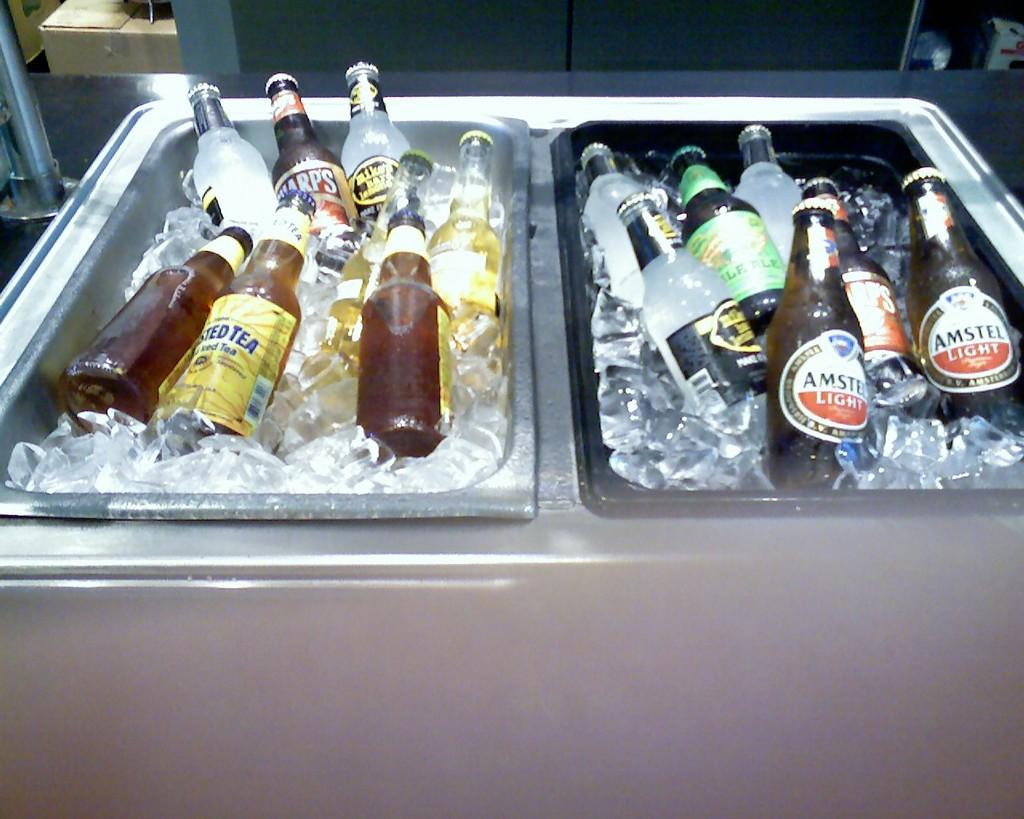<image>
Write a terse but informative summary of the picture. Two bins are filled with ice and beer including Amstel light. 